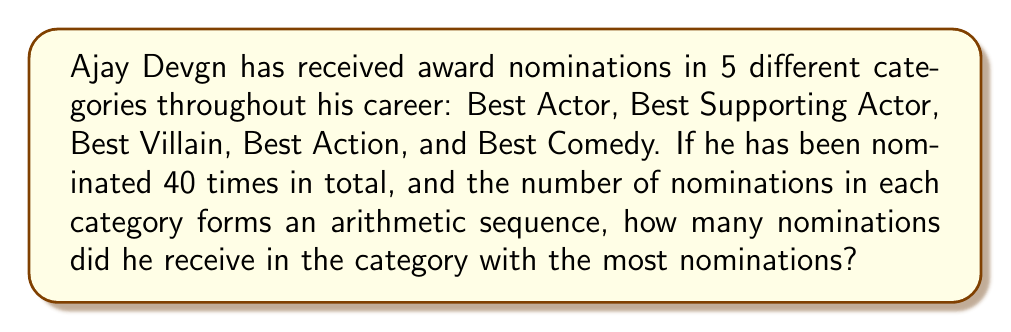Can you answer this question? Let's approach this step-by-step:

1) In an arithmetic sequence, the difference between each term is constant. Let's call this common difference $d$.

2) If we have 5 terms in arithmetic sequence, we can represent them as:
   $a, a+d, a+2d, a+3d, a+4d$
   where $a$ is the smallest number of nominations in a category.

3) The sum of these terms should equal the total nominations:
   $a + (a+d) + (a+2d) + (a+3d) + (a+4d) = 40$

4) Simplifying the left side:
   $5a + 10d = 40$

5) We also know that $a$ and $d$ must be integers, and $a$ must be positive.

6) Through trial and error or systematic checking, we find that $a=4$ and $d=2$ satisfy these conditions.

7) So the sequence of nominations is: 4, 6, 8, 10, 12

8) The largest number in this sequence, 12, represents the category with the most nominations.
Answer: 12 nominations 